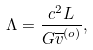Convert formula to latex. <formula><loc_0><loc_0><loc_500><loc_500>\Lambda = \frac { c ^ { 2 } L } { G \overline { v } ^ { ( o ) } } ,</formula> 